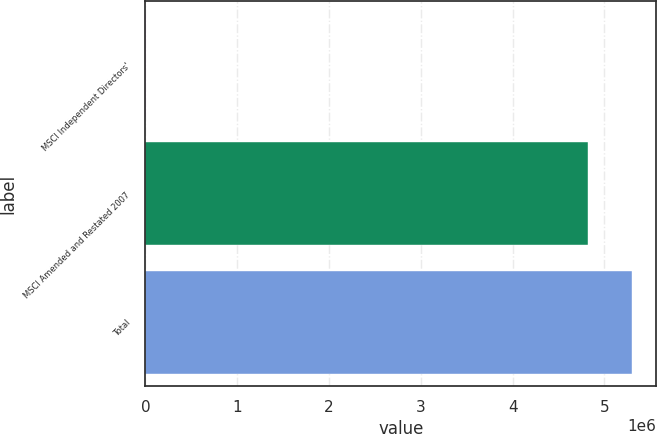Convert chart. <chart><loc_0><loc_0><loc_500><loc_500><bar_chart><fcel>MSCI Independent Directors'<fcel>MSCI Amended and Restated 2007<fcel>Total<nl><fcel>5358<fcel>4.81966e+06<fcel>5.30163e+06<nl></chart> 